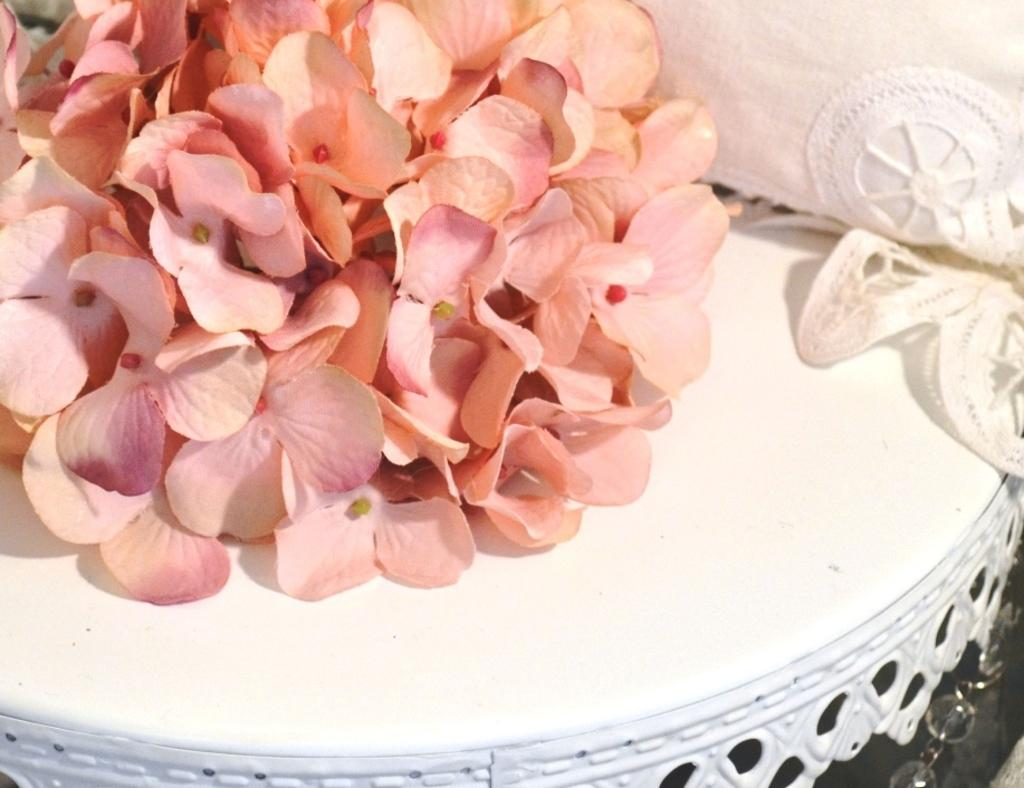What is on the table in the image? There are flowers on a table. What is covering the table in the image? The table has a cloth on it. How much money is on the table in the image? There is no mention of money in the image, so we cannot determine its presence or amount. 